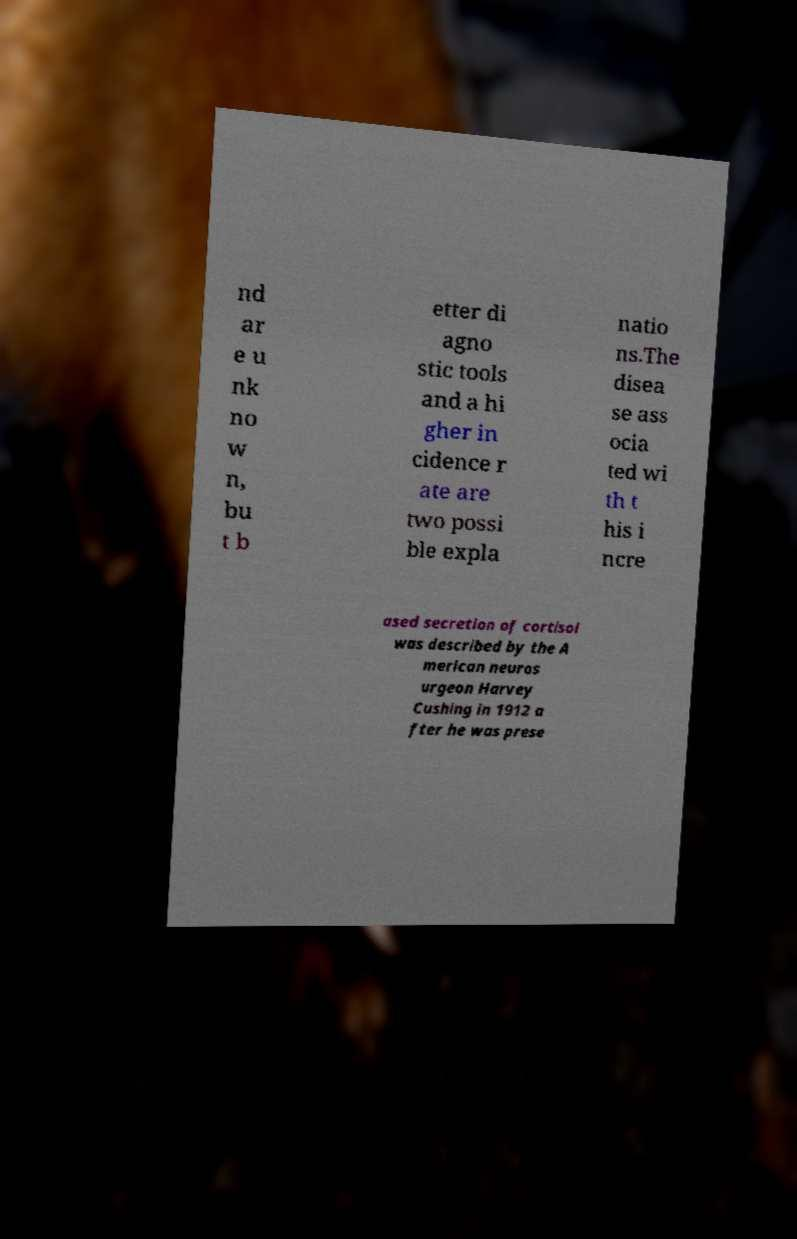Could you extract and type out the text from this image? nd ar e u nk no w n, bu t b etter di agno stic tools and a hi gher in cidence r ate are two possi ble expla natio ns.The disea se ass ocia ted wi th t his i ncre ased secretion of cortisol was described by the A merican neuros urgeon Harvey Cushing in 1912 a fter he was prese 